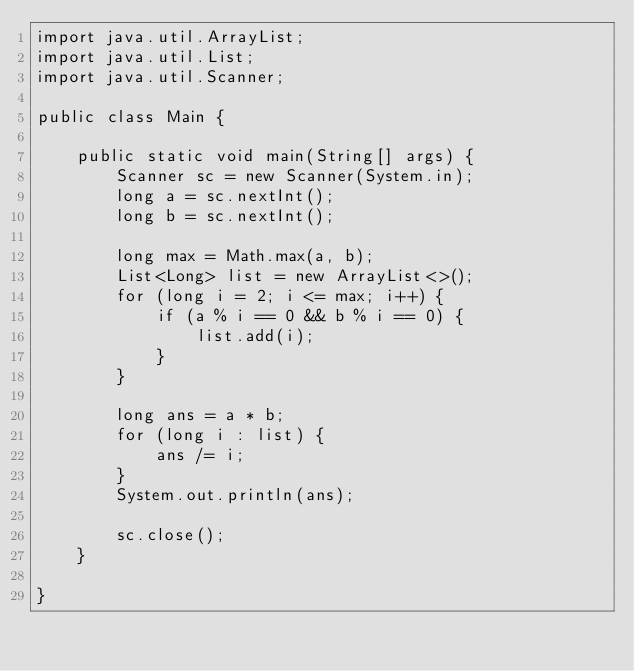Convert code to text. <code><loc_0><loc_0><loc_500><loc_500><_Java_>import java.util.ArrayList;
import java.util.List;
import java.util.Scanner;

public class Main {

    public static void main(String[] args) {
        Scanner sc = new Scanner(System.in);
        long a = sc.nextInt();
        long b = sc.nextInt();

        long max = Math.max(a, b);
        List<Long> list = new ArrayList<>();
        for (long i = 2; i <= max; i++) {
            if (a % i == 0 && b % i == 0) {
                list.add(i);
            }
        }

        long ans = a * b;
        for (long i : list) {
            ans /= i;
        }
        System.out.println(ans);

        sc.close();
    }

}
</code> 